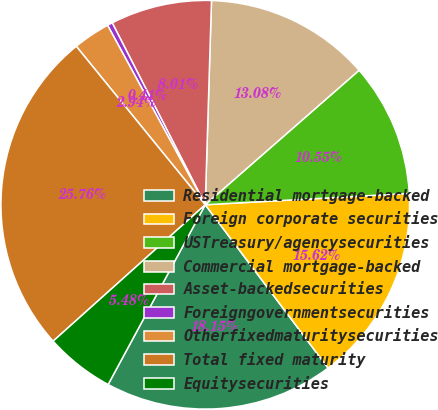<chart> <loc_0><loc_0><loc_500><loc_500><pie_chart><fcel>Residential mortgage-backed<fcel>Foreign corporate securities<fcel>USTreasury/agencysecurities<fcel>Commercial mortgage-backed<fcel>Asset-backedsecurities<fcel>Foreigngovernmentsecurities<fcel>Otherfixedmaturitysecurities<fcel>Total fixed maturity<fcel>Equitysecurities<nl><fcel>18.15%<fcel>15.62%<fcel>10.55%<fcel>13.08%<fcel>8.01%<fcel>0.41%<fcel>2.94%<fcel>25.76%<fcel>5.48%<nl></chart> 